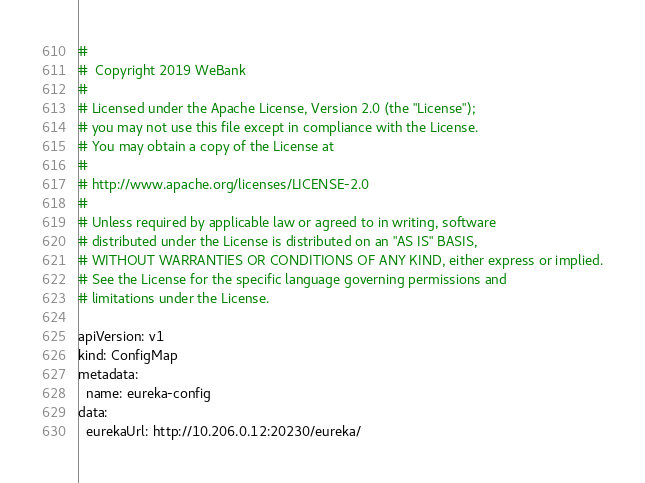Convert code to text. <code><loc_0><loc_0><loc_500><loc_500><_YAML_>#
#  Copyright 2019 WeBank
#
# Licensed under the Apache License, Version 2.0 (the "License");
# you may not use this file except in compliance with the License.
# You may obtain a copy of the License at
#
# http://www.apache.org/licenses/LICENSE-2.0
#
# Unless required by applicable law or agreed to in writing, software
# distributed under the License is distributed on an "AS IS" BASIS,
# WITHOUT WARRANTIES OR CONDITIONS OF ANY KIND, either express or implied.
# See the License for the specific language governing permissions and
# limitations under the License.

apiVersion: v1
kind: ConfigMap
metadata:
  name: eureka-config
data:
  eurekaUrl: http://10.206.0.12:20230/eureka/

</code> 